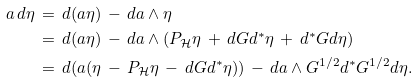<formula> <loc_0><loc_0><loc_500><loc_500>a \, d \eta \, & = \, d ( a \eta ) \, - \, d a \wedge \eta \\ & = \, d ( a \eta ) \, - \, d a \wedge ( P _ { \mathcal { H } } \eta \, + \, d G d ^ { * } \eta \, + \, d ^ { * } G d \eta ) \\ & = \, d ( a ( \eta \, - \, P _ { \mathcal { H } } \eta \, - \, d G d ^ { * } \eta ) ) \, - \, d a \wedge G ^ { 1 / 2 } d ^ { * } G ^ { 1 / 2 } d \eta .</formula> 